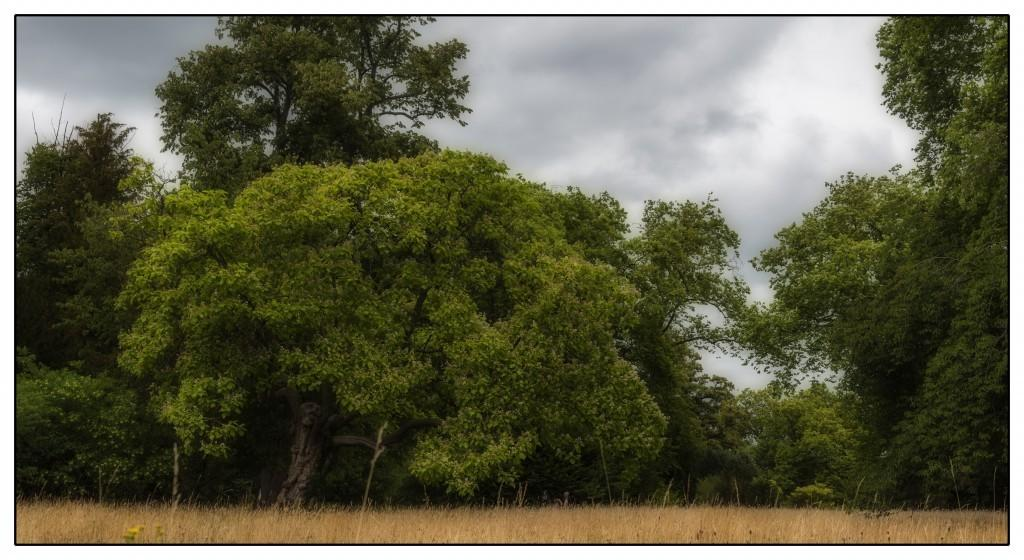What type of vegetation is visible in the front of the image? There is dry grass in the front of the image. What can be seen in the background of the image? There are trees in the background of the image. How would you describe the sky in the image? The sky is cloudy in the image. What type of mine is visible in the image? There is no mine present in the image. Can you recite a verse from a poem that is visible in the image? There are no verses or poems visible in the image. 